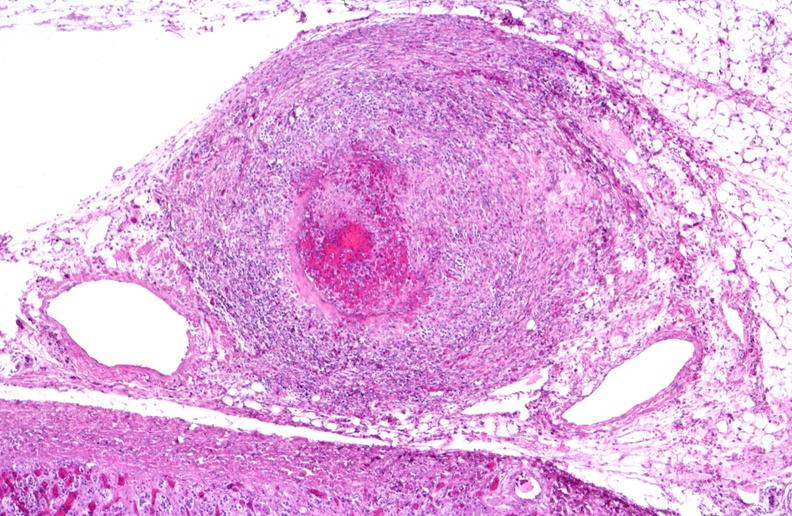s vasculature present?
Answer the question using a single word or phrase. Yes 